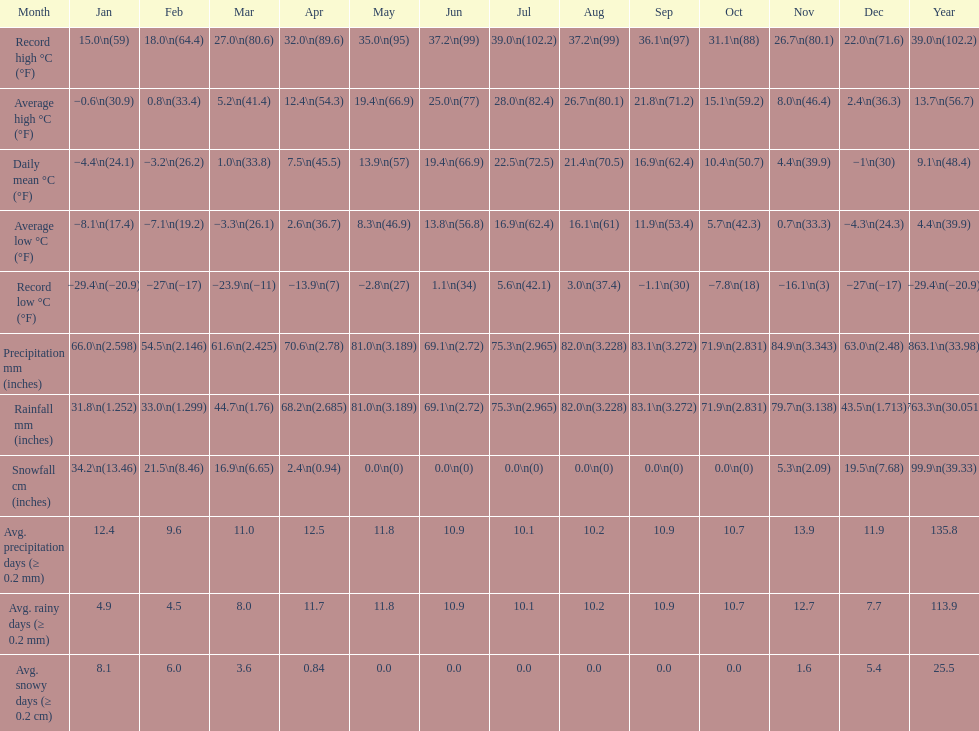How many months had a record high of over 15.0 degrees? 11. Would you be able to parse every entry in this table? {'header': ['Month', 'Jan', 'Feb', 'Mar', 'Apr', 'May', 'Jun', 'Jul', 'Aug', 'Sep', 'Oct', 'Nov', 'Dec', 'Year'], 'rows': [['Record high °C (°F)', '15.0\\n(59)', '18.0\\n(64.4)', '27.0\\n(80.6)', '32.0\\n(89.6)', '35.0\\n(95)', '37.2\\n(99)', '39.0\\n(102.2)', '37.2\\n(99)', '36.1\\n(97)', '31.1\\n(88)', '26.7\\n(80.1)', '22.0\\n(71.6)', '39.0\\n(102.2)'], ['Average high °C (°F)', '−0.6\\n(30.9)', '0.8\\n(33.4)', '5.2\\n(41.4)', '12.4\\n(54.3)', '19.4\\n(66.9)', '25.0\\n(77)', '28.0\\n(82.4)', '26.7\\n(80.1)', '21.8\\n(71.2)', '15.1\\n(59.2)', '8.0\\n(46.4)', '2.4\\n(36.3)', '13.7\\n(56.7)'], ['Daily mean °C (°F)', '−4.4\\n(24.1)', '−3.2\\n(26.2)', '1.0\\n(33.8)', '7.5\\n(45.5)', '13.9\\n(57)', '19.4\\n(66.9)', '22.5\\n(72.5)', '21.4\\n(70.5)', '16.9\\n(62.4)', '10.4\\n(50.7)', '4.4\\n(39.9)', '−1\\n(30)', '9.1\\n(48.4)'], ['Average low °C (°F)', '−8.1\\n(17.4)', '−7.1\\n(19.2)', '−3.3\\n(26.1)', '2.6\\n(36.7)', '8.3\\n(46.9)', '13.8\\n(56.8)', '16.9\\n(62.4)', '16.1\\n(61)', '11.9\\n(53.4)', '5.7\\n(42.3)', '0.7\\n(33.3)', '−4.3\\n(24.3)', '4.4\\n(39.9)'], ['Record low °C (°F)', '−29.4\\n(−20.9)', '−27\\n(−17)', '−23.9\\n(−11)', '−13.9\\n(7)', '−2.8\\n(27)', '1.1\\n(34)', '5.6\\n(42.1)', '3.0\\n(37.4)', '−1.1\\n(30)', '−7.8\\n(18)', '−16.1\\n(3)', '−27\\n(−17)', '−29.4\\n(−20.9)'], ['Precipitation mm (inches)', '66.0\\n(2.598)', '54.5\\n(2.146)', '61.6\\n(2.425)', '70.6\\n(2.78)', '81.0\\n(3.189)', '69.1\\n(2.72)', '75.3\\n(2.965)', '82.0\\n(3.228)', '83.1\\n(3.272)', '71.9\\n(2.831)', '84.9\\n(3.343)', '63.0\\n(2.48)', '863.1\\n(33.98)'], ['Rainfall mm (inches)', '31.8\\n(1.252)', '33.0\\n(1.299)', '44.7\\n(1.76)', '68.2\\n(2.685)', '81.0\\n(3.189)', '69.1\\n(2.72)', '75.3\\n(2.965)', '82.0\\n(3.228)', '83.1\\n(3.272)', '71.9\\n(2.831)', '79.7\\n(3.138)', '43.5\\n(1.713)', '763.3\\n(30.051)'], ['Snowfall cm (inches)', '34.2\\n(13.46)', '21.5\\n(8.46)', '16.9\\n(6.65)', '2.4\\n(0.94)', '0.0\\n(0)', '0.0\\n(0)', '0.0\\n(0)', '0.0\\n(0)', '0.0\\n(0)', '0.0\\n(0)', '5.3\\n(2.09)', '19.5\\n(7.68)', '99.9\\n(39.33)'], ['Avg. precipitation days (≥ 0.2 mm)', '12.4', '9.6', '11.0', '12.5', '11.8', '10.9', '10.1', '10.2', '10.9', '10.7', '13.9', '11.9', '135.8'], ['Avg. rainy days (≥ 0.2 mm)', '4.9', '4.5', '8.0', '11.7', '11.8', '10.9', '10.1', '10.2', '10.9', '10.7', '12.7', '7.7', '113.9'], ['Avg. snowy days (≥ 0.2 cm)', '8.1', '6.0', '3.6', '0.84', '0.0', '0.0', '0.0', '0.0', '0.0', '0.0', '1.6', '5.4', '25.5']]} 